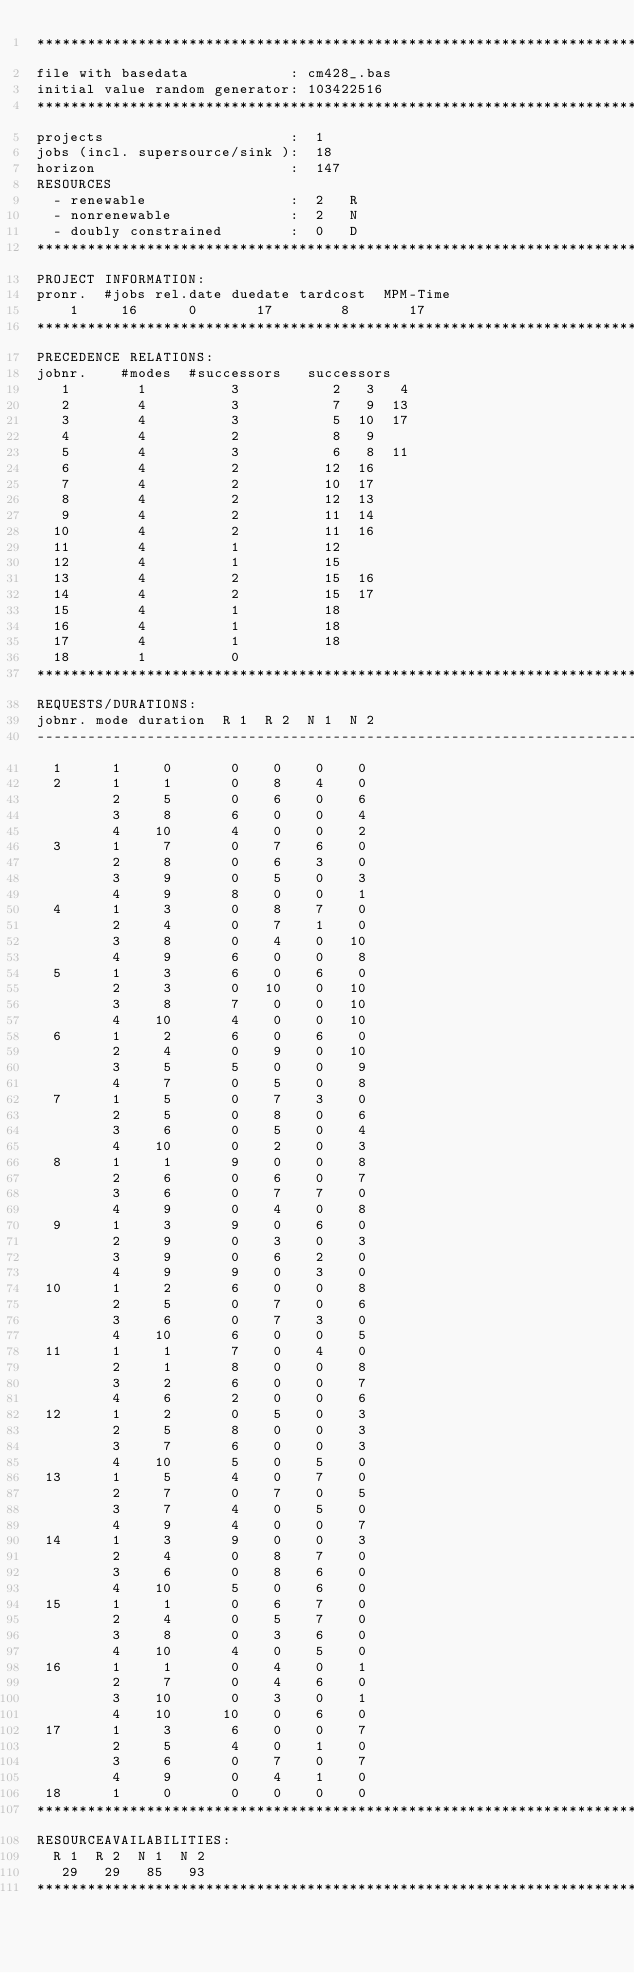<code> <loc_0><loc_0><loc_500><loc_500><_ObjectiveC_>************************************************************************
file with basedata            : cm428_.bas
initial value random generator: 103422516
************************************************************************
projects                      :  1
jobs (incl. supersource/sink ):  18
horizon                       :  147
RESOURCES
  - renewable                 :  2   R
  - nonrenewable              :  2   N
  - doubly constrained        :  0   D
************************************************************************
PROJECT INFORMATION:
pronr.  #jobs rel.date duedate tardcost  MPM-Time
    1     16      0       17        8       17
************************************************************************
PRECEDENCE RELATIONS:
jobnr.    #modes  #successors   successors
   1        1          3           2   3   4
   2        4          3           7   9  13
   3        4          3           5  10  17
   4        4          2           8   9
   5        4          3           6   8  11
   6        4          2          12  16
   7        4          2          10  17
   8        4          2          12  13
   9        4          2          11  14
  10        4          2          11  16
  11        4          1          12
  12        4          1          15
  13        4          2          15  16
  14        4          2          15  17
  15        4          1          18
  16        4          1          18
  17        4          1          18
  18        1          0        
************************************************************************
REQUESTS/DURATIONS:
jobnr. mode duration  R 1  R 2  N 1  N 2
------------------------------------------------------------------------
  1      1     0       0    0    0    0
  2      1     1       0    8    4    0
         2     5       0    6    0    6
         3     8       6    0    0    4
         4    10       4    0    0    2
  3      1     7       0    7    6    0
         2     8       0    6    3    0
         3     9       0    5    0    3
         4     9       8    0    0    1
  4      1     3       0    8    7    0
         2     4       0    7    1    0
         3     8       0    4    0   10
         4     9       6    0    0    8
  5      1     3       6    0    6    0
         2     3       0   10    0   10
         3     8       7    0    0   10
         4    10       4    0    0   10
  6      1     2       6    0    6    0
         2     4       0    9    0   10
         3     5       5    0    0    9
         4     7       0    5    0    8
  7      1     5       0    7    3    0
         2     5       0    8    0    6
         3     6       0    5    0    4
         4    10       0    2    0    3
  8      1     1       9    0    0    8
         2     6       0    6    0    7
         3     6       0    7    7    0
         4     9       0    4    0    8
  9      1     3       9    0    6    0
         2     9       0    3    0    3
         3     9       0    6    2    0
         4     9       9    0    3    0
 10      1     2       6    0    0    8
         2     5       0    7    0    6
         3     6       0    7    3    0
         4    10       6    0    0    5
 11      1     1       7    0    4    0
         2     1       8    0    0    8
         3     2       6    0    0    7
         4     6       2    0    0    6
 12      1     2       0    5    0    3
         2     5       8    0    0    3
         3     7       6    0    0    3
         4    10       5    0    5    0
 13      1     5       4    0    7    0
         2     7       0    7    0    5
         3     7       4    0    5    0
         4     9       4    0    0    7
 14      1     3       9    0    0    3
         2     4       0    8    7    0
         3     6       0    8    6    0
         4    10       5    0    6    0
 15      1     1       0    6    7    0
         2     4       0    5    7    0
         3     8       0    3    6    0
         4    10       4    0    5    0
 16      1     1       0    4    0    1
         2     7       0    4    6    0
         3    10       0    3    0    1
         4    10      10    0    6    0
 17      1     3       6    0    0    7
         2     5       4    0    1    0
         3     6       0    7    0    7
         4     9       0    4    1    0
 18      1     0       0    0    0    0
************************************************************************
RESOURCEAVAILABILITIES:
  R 1  R 2  N 1  N 2
   29   29   85   93
************************************************************************
</code> 